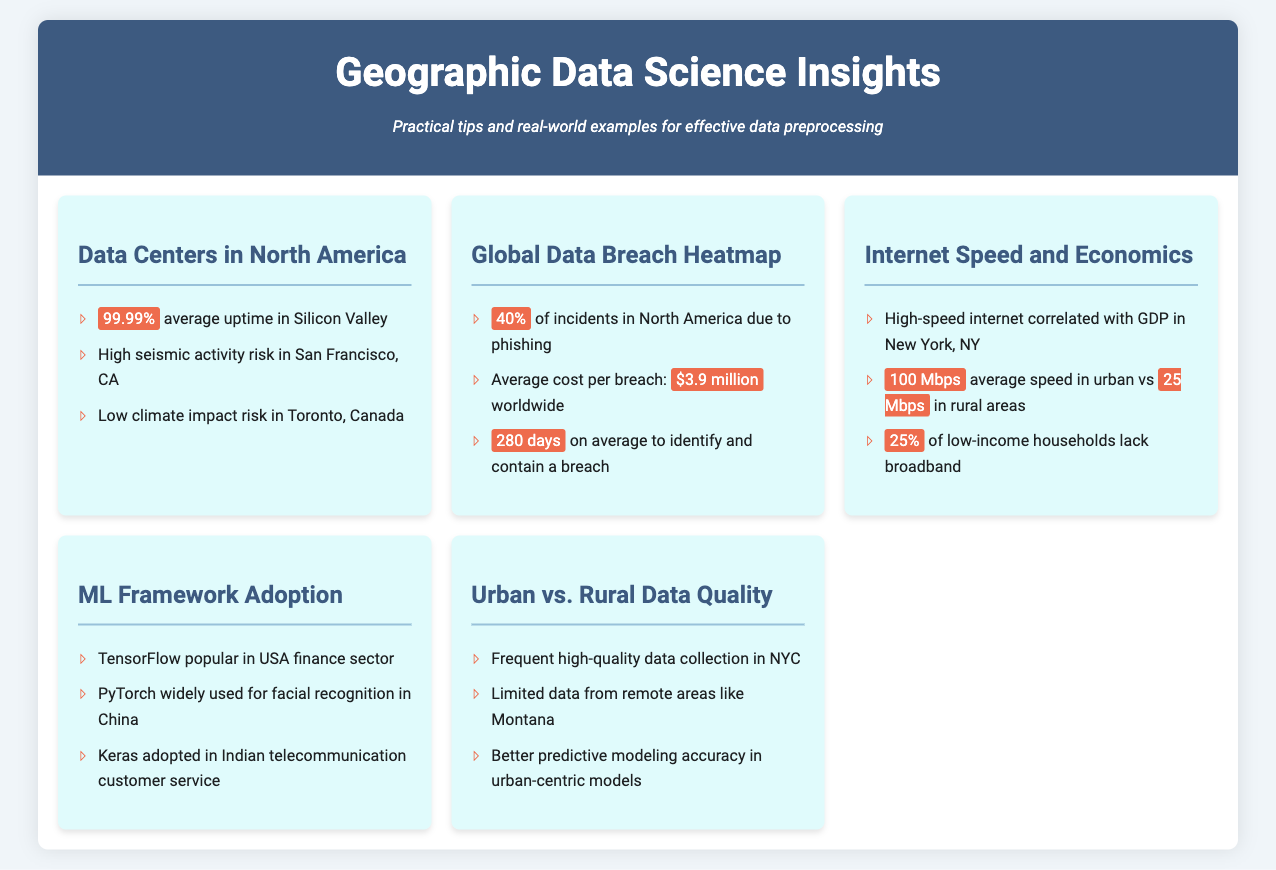What is the average uptime in Silicon Valley? The document states that the average uptime in Silicon Valley is 99.99%.
Answer: 99.99% What is the average cost per data breach worldwide? The document mentions that the average cost per breach worldwide is $3.9 million.
Answer: $3.9 million What is the average internet speed in urban areas? According to the document, the average speed in urban areas is 100 Mbps.
Answer: 100 Mbps Which machine learning framework is popular in the USA finance sector? The document indicates that TensorFlow is popular in the USA finance sector.
Answer: TensorFlow What is the percentage of low-income households lacking broadband? The document states that 25% of low-income households lack broadband.
Answer: 25% Why is data quality better in urban-centric models? The document explains that there's frequent high-quality data collection in cities like NYC, influencing model accuracy.
Answer: Frequent high-quality data collection Which city has limited data from remote areas? The document specifies that Montana has limited data from remote areas.
Answer: Montana What is the time taken to identify and contain a data breach on average? The document indicates that it takes 280 days on average to identify and contain a breach.
Answer: 280 days What is the average internet speed in rural areas? The document states that the average speed in rural areas is 25 Mbps.
Answer: 25 Mbps 